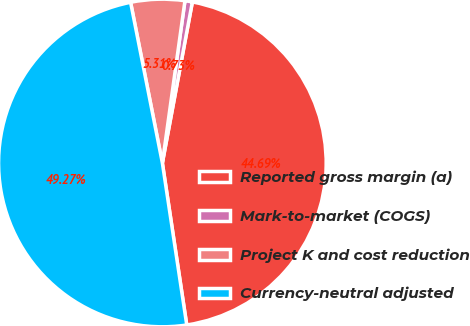Convert chart. <chart><loc_0><loc_0><loc_500><loc_500><pie_chart><fcel>Reported gross margin (a)<fcel>Mark-to-market (COGS)<fcel>Project K and cost reduction<fcel>Currency-neutral adjusted<nl><fcel>44.69%<fcel>0.73%<fcel>5.31%<fcel>49.27%<nl></chart> 